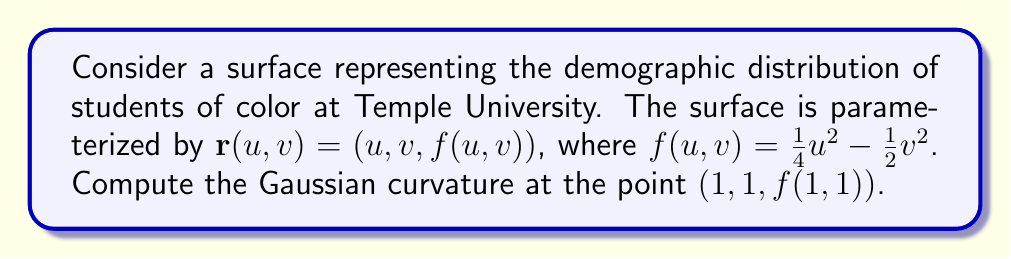Give your solution to this math problem. To compute the Gaussian curvature, we need to follow these steps:

1. Calculate the first fundamental form coefficients:
   $E = \mathbf{r}_u \cdot \mathbf{r}_u$
   $F = \mathbf{r}_u \cdot \mathbf{r}_v$
   $G = \mathbf{r}_v \cdot \mathbf{r}_v$

2. Calculate the second fundamental form coefficients:
   $e = \mathbf{n} \cdot \mathbf{r}_{uu}$
   $f = \mathbf{n} \cdot \mathbf{r}_{uv}$
   $g = \mathbf{n} \cdot \mathbf{r}_{vv}$

3. Compute the Gaussian curvature using the formula:
   $K = \frac{eg - f^2}{EG - F^2}$

Step 1: First fundamental form coefficients
$\mathbf{r}_u = (1, 0, \frac{1}{2}u)$
$\mathbf{r}_v = (0, 1, -v)$

$E = 1 + (\frac{1}{2}u)^2 = 1 + \frac{1}{4}u^2$
$F = 0$
$G = 1 + v^2$

Step 2: Second fundamental form coefficients
$\mathbf{r}_{uu} = (0, 0, \frac{1}{2})$
$\mathbf{r}_{uv} = (0, 0, 0)$
$\mathbf{r}_{vv} = (0, 0, -1)$

Normal vector:
$\mathbf{n} = \frac{\mathbf{r}_u \times \mathbf{r}_v}{|\mathbf{r}_u \times \mathbf{r}_v|} = \frac{(-\frac{1}{2}u, v, 1)}{\sqrt{1 + \frac{1}{4}u^2 + v^2}}$

$e = \frac{1}{2\sqrt{1 + \frac{1}{4}u^2 + v^2}}$
$f = 0$
$g = \frac{-1}{\sqrt{1 + \frac{1}{4}u^2 + v^2}}$

Step 3: Gaussian curvature
$K = \frac{eg - f^2}{EG - F^2} = \frac{(\frac{1}{2})(-1) - 0^2}{(1 + \frac{1}{4}u^2)(1 + v^2) - 0^2} = \frac{-\frac{1}{2}}{(1 + \frac{1}{4}u^2)(1 + v^2)}$

At the point $(1,1,f(1,1))$:
$K = \frac{-\frac{1}{2}}{(1 + \frac{1}{4})(1 + 1)} = \frac{-\frac{1}{2}}{\frac{5}{4} \cdot 2} = -\frac{1}{5}$
Answer: $K = -\frac{1}{5}$ 